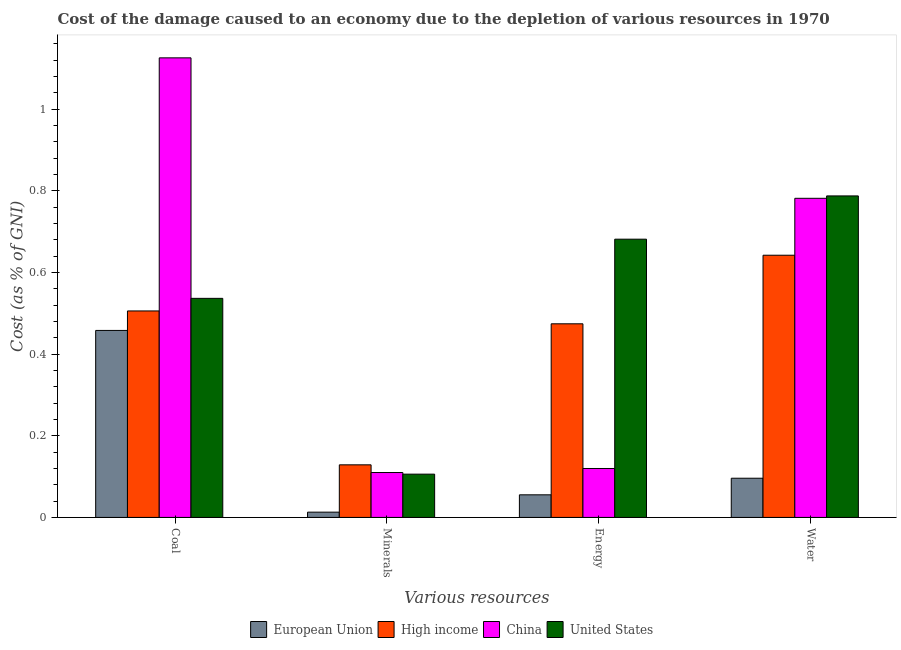How many groups of bars are there?
Give a very brief answer. 4. Are the number of bars per tick equal to the number of legend labels?
Make the answer very short. Yes. How many bars are there on the 3rd tick from the left?
Provide a short and direct response. 4. How many bars are there on the 3rd tick from the right?
Give a very brief answer. 4. What is the label of the 3rd group of bars from the left?
Your answer should be compact. Energy. What is the cost of damage due to depletion of coal in High income?
Provide a short and direct response. 0.51. Across all countries, what is the maximum cost of damage due to depletion of minerals?
Your answer should be compact. 0.13. Across all countries, what is the minimum cost of damage due to depletion of water?
Provide a succinct answer. 0.1. In which country was the cost of damage due to depletion of minerals minimum?
Your response must be concise. European Union. What is the total cost of damage due to depletion of coal in the graph?
Give a very brief answer. 2.63. What is the difference between the cost of damage due to depletion of energy in High income and that in United States?
Ensure brevity in your answer.  -0.21. What is the difference between the cost of damage due to depletion of minerals in United States and the cost of damage due to depletion of coal in European Union?
Provide a succinct answer. -0.35. What is the average cost of damage due to depletion of water per country?
Offer a terse response. 0.58. What is the difference between the cost of damage due to depletion of water and cost of damage due to depletion of minerals in European Union?
Offer a very short reply. 0.08. What is the ratio of the cost of damage due to depletion of water in United States to that in European Union?
Give a very brief answer. 8.2. Is the cost of damage due to depletion of coal in United States less than that in European Union?
Provide a succinct answer. No. What is the difference between the highest and the second highest cost of damage due to depletion of energy?
Ensure brevity in your answer.  0.21. What is the difference between the highest and the lowest cost of damage due to depletion of coal?
Ensure brevity in your answer.  0.67. In how many countries, is the cost of damage due to depletion of coal greater than the average cost of damage due to depletion of coal taken over all countries?
Offer a terse response. 1. Is the sum of the cost of damage due to depletion of coal in China and High income greater than the maximum cost of damage due to depletion of minerals across all countries?
Your answer should be compact. Yes. How many countries are there in the graph?
Your answer should be very brief. 4. Does the graph contain grids?
Give a very brief answer. No. Where does the legend appear in the graph?
Give a very brief answer. Bottom center. How are the legend labels stacked?
Provide a short and direct response. Horizontal. What is the title of the graph?
Give a very brief answer. Cost of the damage caused to an economy due to the depletion of various resources in 1970 . Does "Armenia" appear as one of the legend labels in the graph?
Your response must be concise. No. What is the label or title of the X-axis?
Your answer should be compact. Various resources. What is the label or title of the Y-axis?
Your response must be concise. Cost (as % of GNI). What is the Cost (as % of GNI) of European Union in Coal?
Your response must be concise. 0.46. What is the Cost (as % of GNI) of High income in Coal?
Offer a terse response. 0.51. What is the Cost (as % of GNI) in China in Coal?
Your response must be concise. 1.13. What is the Cost (as % of GNI) in United States in Coal?
Your answer should be very brief. 0.54. What is the Cost (as % of GNI) in European Union in Minerals?
Provide a succinct answer. 0.01. What is the Cost (as % of GNI) of High income in Minerals?
Your answer should be compact. 0.13. What is the Cost (as % of GNI) in China in Minerals?
Offer a terse response. 0.11. What is the Cost (as % of GNI) of United States in Minerals?
Provide a succinct answer. 0.11. What is the Cost (as % of GNI) of European Union in Energy?
Make the answer very short. 0.06. What is the Cost (as % of GNI) of High income in Energy?
Keep it short and to the point. 0.47. What is the Cost (as % of GNI) of China in Energy?
Your answer should be very brief. 0.12. What is the Cost (as % of GNI) in United States in Energy?
Make the answer very short. 0.68. What is the Cost (as % of GNI) in European Union in Water?
Your answer should be compact. 0.1. What is the Cost (as % of GNI) of High income in Water?
Make the answer very short. 0.64. What is the Cost (as % of GNI) of China in Water?
Provide a short and direct response. 0.78. What is the Cost (as % of GNI) of United States in Water?
Offer a terse response. 0.79. Across all Various resources, what is the maximum Cost (as % of GNI) of European Union?
Give a very brief answer. 0.46. Across all Various resources, what is the maximum Cost (as % of GNI) of High income?
Provide a short and direct response. 0.64. Across all Various resources, what is the maximum Cost (as % of GNI) of China?
Your answer should be very brief. 1.13. Across all Various resources, what is the maximum Cost (as % of GNI) of United States?
Make the answer very short. 0.79. Across all Various resources, what is the minimum Cost (as % of GNI) of European Union?
Make the answer very short. 0.01. Across all Various resources, what is the minimum Cost (as % of GNI) of High income?
Provide a short and direct response. 0.13. Across all Various resources, what is the minimum Cost (as % of GNI) of China?
Provide a short and direct response. 0.11. Across all Various resources, what is the minimum Cost (as % of GNI) of United States?
Your answer should be very brief. 0.11. What is the total Cost (as % of GNI) of European Union in the graph?
Your answer should be compact. 0.62. What is the total Cost (as % of GNI) of High income in the graph?
Your answer should be very brief. 1.75. What is the total Cost (as % of GNI) in China in the graph?
Provide a short and direct response. 2.14. What is the total Cost (as % of GNI) of United States in the graph?
Your answer should be very brief. 2.11. What is the difference between the Cost (as % of GNI) of European Union in Coal and that in Minerals?
Make the answer very short. 0.45. What is the difference between the Cost (as % of GNI) of High income in Coal and that in Minerals?
Make the answer very short. 0.38. What is the difference between the Cost (as % of GNI) in China in Coal and that in Minerals?
Your answer should be very brief. 1.02. What is the difference between the Cost (as % of GNI) of United States in Coal and that in Minerals?
Ensure brevity in your answer.  0.43. What is the difference between the Cost (as % of GNI) in European Union in Coal and that in Energy?
Your answer should be compact. 0.4. What is the difference between the Cost (as % of GNI) in High income in Coal and that in Energy?
Your answer should be compact. 0.03. What is the difference between the Cost (as % of GNI) of China in Coal and that in Energy?
Your answer should be very brief. 1.01. What is the difference between the Cost (as % of GNI) of United States in Coal and that in Energy?
Ensure brevity in your answer.  -0.14. What is the difference between the Cost (as % of GNI) in European Union in Coal and that in Water?
Your response must be concise. 0.36. What is the difference between the Cost (as % of GNI) of High income in Coal and that in Water?
Your answer should be very brief. -0.14. What is the difference between the Cost (as % of GNI) of China in Coal and that in Water?
Offer a very short reply. 0.34. What is the difference between the Cost (as % of GNI) in United States in Coal and that in Water?
Your answer should be very brief. -0.25. What is the difference between the Cost (as % of GNI) in European Union in Minerals and that in Energy?
Make the answer very short. -0.04. What is the difference between the Cost (as % of GNI) in High income in Minerals and that in Energy?
Ensure brevity in your answer.  -0.35. What is the difference between the Cost (as % of GNI) in China in Minerals and that in Energy?
Your answer should be very brief. -0.01. What is the difference between the Cost (as % of GNI) in United States in Minerals and that in Energy?
Offer a terse response. -0.58. What is the difference between the Cost (as % of GNI) in European Union in Minerals and that in Water?
Keep it short and to the point. -0.08. What is the difference between the Cost (as % of GNI) of High income in Minerals and that in Water?
Give a very brief answer. -0.51. What is the difference between the Cost (as % of GNI) in China in Minerals and that in Water?
Provide a short and direct response. -0.67. What is the difference between the Cost (as % of GNI) of United States in Minerals and that in Water?
Keep it short and to the point. -0.68. What is the difference between the Cost (as % of GNI) of European Union in Energy and that in Water?
Make the answer very short. -0.04. What is the difference between the Cost (as % of GNI) in High income in Energy and that in Water?
Give a very brief answer. -0.17. What is the difference between the Cost (as % of GNI) of China in Energy and that in Water?
Offer a terse response. -0.66. What is the difference between the Cost (as % of GNI) in United States in Energy and that in Water?
Offer a terse response. -0.11. What is the difference between the Cost (as % of GNI) of European Union in Coal and the Cost (as % of GNI) of High income in Minerals?
Give a very brief answer. 0.33. What is the difference between the Cost (as % of GNI) of European Union in Coal and the Cost (as % of GNI) of China in Minerals?
Provide a succinct answer. 0.35. What is the difference between the Cost (as % of GNI) of European Union in Coal and the Cost (as % of GNI) of United States in Minerals?
Offer a very short reply. 0.35. What is the difference between the Cost (as % of GNI) in High income in Coal and the Cost (as % of GNI) in China in Minerals?
Offer a terse response. 0.4. What is the difference between the Cost (as % of GNI) in High income in Coal and the Cost (as % of GNI) in United States in Minerals?
Provide a succinct answer. 0.4. What is the difference between the Cost (as % of GNI) of China in Coal and the Cost (as % of GNI) of United States in Minerals?
Make the answer very short. 1.02. What is the difference between the Cost (as % of GNI) of European Union in Coal and the Cost (as % of GNI) of High income in Energy?
Offer a very short reply. -0.02. What is the difference between the Cost (as % of GNI) of European Union in Coal and the Cost (as % of GNI) of China in Energy?
Offer a very short reply. 0.34. What is the difference between the Cost (as % of GNI) of European Union in Coal and the Cost (as % of GNI) of United States in Energy?
Make the answer very short. -0.22. What is the difference between the Cost (as % of GNI) in High income in Coal and the Cost (as % of GNI) in China in Energy?
Your answer should be compact. 0.39. What is the difference between the Cost (as % of GNI) of High income in Coal and the Cost (as % of GNI) of United States in Energy?
Your response must be concise. -0.18. What is the difference between the Cost (as % of GNI) in China in Coal and the Cost (as % of GNI) in United States in Energy?
Your answer should be very brief. 0.44. What is the difference between the Cost (as % of GNI) of European Union in Coal and the Cost (as % of GNI) of High income in Water?
Give a very brief answer. -0.18. What is the difference between the Cost (as % of GNI) of European Union in Coal and the Cost (as % of GNI) of China in Water?
Your response must be concise. -0.32. What is the difference between the Cost (as % of GNI) of European Union in Coal and the Cost (as % of GNI) of United States in Water?
Offer a terse response. -0.33. What is the difference between the Cost (as % of GNI) in High income in Coal and the Cost (as % of GNI) in China in Water?
Provide a succinct answer. -0.28. What is the difference between the Cost (as % of GNI) of High income in Coal and the Cost (as % of GNI) of United States in Water?
Offer a very short reply. -0.28. What is the difference between the Cost (as % of GNI) in China in Coal and the Cost (as % of GNI) in United States in Water?
Your response must be concise. 0.34. What is the difference between the Cost (as % of GNI) of European Union in Minerals and the Cost (as % of GNI) of High income in Energy?
Make the answer very short. -0.46. What is the difference between the Cost (as % of GNI) of European Union in Minerals and the Cost (as % of GNI) of China in Energy?
Make the answer very short. -0.11. What is the difference between the Cost (as % of GNI) in European Union in Minerals and the Cost (as % of GNI) in United States in Energy?
Your answer should be very brief. -0.67. What is the difference between the Cost (as % of GNI) of High income in Minerals and the Cost (as % of GNI) of China in Energy?
Offer a very short reply. 0.01. What is the difference between the Cost (as % of GNI) of High income in Minerals and the Cost (as % of GNI) of United States in Energy?
Offer a terse response. -0.55. What is the difference between the Cost (as % of GNI) in China in Minerals and the Cost (as % of GNI) in United States in Energy?
Your answer should be very brief. -0.57. What is the difference between the Cost (as % of GNI) of European Union in Minerals and the Cost (as % of GNI) of High income in Water?
Give a very brief answer. -0.63. What is the difference between the Cost (as % of GNI) of European Union in Minerals and the Cost (as % of GNI) of China in Water?
Keep it short and to the point. -0.77. What is the difference between the Cost (as % of GNI) of European Union in Minerals and the Cost (as % of GNI) of United States in Water?
Give a very brief answer. -0.77. What is the difference between the Cost (as % of GNI) of High income in Minerals and the Cost (as % of GNI) of China in Water?
Give a very brief answer. -0.65. What is the difference between the Cost (as % of GNI) of High income in Minerals and the Cost (as % of GNI) of United States in Water?
Provide a short and direct response. -0.66. What is the difference between the Cost (as % of GNI) of China in Minerals and the Cost (as % of GNI) of United States in Water?
Offer a terse response. -0.68. What is the difference between the Cost (as % of GNI) of European Union in Energy and the Cost (as % of GNI) of High income in Water?
Your answer should be compact. -0.59. What is the difference between the Cost (as % of GNI) in European Union in Energy and the Cost (as % of GNI) in China in Water?
Offer a terse response. -0.73. What is the difference between the Cost (as % of GNI) of European Union in Energy and the Cost (as % of GNI) of United States in Water?
Ensure brevity in your answer.  -0.73. What is the difference between the Cost (as % of GNI) of High income in Energy and the Cost (as % of GNI) of China in Water?
Provide a succinct answer. -0.31. What is the difference between the Cost (as % of GNI) of High income in Energy and the Cost (as % of GNI) of United States in Water?
Your response must be concise. -0.31. What is the difference between the Cost (as % of GNI) of China in Energy and the Cost (as % of GNI) of United States in Water?
Keep it short and to the point. -0.67. What is the average Cost (as % of GNI) in European Union per Various resources?
Provide a succinct answer. 0.16. What is the average Cost (as % of GNI) of High income per Various resources?
Your answer should be very brief. 0.44. What is the average Cost (as % of GNI) in China per Various resources?
Your response must be concise. 0.53. What is the average Cost (as % of GNI) of United States per Various resources?
Give a very brief answer. 0.53. What is the difference between the Cost (as % of GNI) in European Union and Cost (as % of GNI) in High income in Coal?
Your response must be concise. -0.05. What is the difference between the Cost (as % of GNI) of European Union and Cost (as % of GNI) of China in Coal?
Provide a short and direct response. -0.67. What is the difference between the Cost (as % of GNI) in European Union and Cost (as % of GNI) in United States in Coal?
Keep it short and to the point. -0.08. What is the difference between the Cost (as % of GNI) in High income and Cost (as % of GNI) in China in Coal?
Offer a terse response. -0.62. What is the difference between the Cost (as % of GNI) in High income and Cost (as % of GNI) in United States in Coal?
Give a very brief answer. -0.03. What is the difference between the Cost (as % of GNI) of China and Cost (as % of GNI) of United States in Coal?
Offer a terse response. 0.59. What is the difference between the Cost (as % of GNI) of European Union and Cost (as % of GNI) of High income in Minerals?
Ensure brevity in your answer.  -0.12. What is the difference between the Cost (as % of GNI) of European Union and Cost (as % of GNI) of China in Minerals?
Provide a short and direct response. -0.1. What is the difference between the Cost (as % of GNI) in European Union and Cost (as % of GNI) in United States in Minerals?
Keep it short and to the point. -0.09. What is the difference between the Cost (as % of GNI) of High income and Cost (as % of GNI) of China in Minerals?
Provide a succinct answer. 0.02. What is the difference between the Cost (as % of GNI) of High income and Cost (as % of GNI) of United States in Minerals?
Provide a short and direct response. 0.02. What is the difference between the Cost (as % of GNI) of China and Cost (as % of GNI) of United States in Minerals?
Your answer should be compact. 0. What is the difference between the Cost (as % of GNI) of European Union and Cost (as % of GNI) of High income in Energy?
Offer a terse response. -0.42. What is the difference between the Cost (as % of GNI) in European Union and Cost (as % of GNI) in China in Energy?
Offer a very short reply. -0.06. What is the difference between the Cost (as % of GNI) of European Union and Cost (as % of GNI) of United States in Energy?
Your response must be concise. -0.63. What is the difference between the Cost (as % of GNI) of High income and Cost (as % of GNI) of China in Energy?
Ensure brevity in your answer.  0.35. What is the difference between the Cost (as % of GNI) of High income and Cost (as % of GNI) of United States in Energy?
Your response must be concise. -0.21. What is the difference between the Cost (as % of GNI) in China and Cost (as % of GNI) in United States in Energy?
Make the answer very short. -0.56. What is the difference between the Cost (as % of GNI) of European Union and Cost (as % of GNI) of High income in Water?
Ensure brevity in your answer.  -0.55. What is the difference between the Cost (as % of GNI) of European Union and Cost (as % of GNI) of China in Water?
Give a very brief answer. -0.69. What is the difference between the Cost (as % of GNI) in European Union and Cost (as % of GNI) in United States in Water?
Give a very brief answer. -0.69. What is the difference between the Cost (as % of GNI) of High income and Cost (as % of GNI) of China in Water?
Provide a short and direct response. -0.14. What is the difference between the Cost (as % of GNI) of High income and Cost (as % of GNI) of United States in Water?
Provide a succinct answer. -0.15. What is the difference between the Cost (as % of GNI) in China and Cost (as % of GNI) in United States in Water?
Your answer should be very brief. -0.01. What is the ratio of the Cost (as % of GNI) of European Union in Coal to that in Minerals?
Your answer should be compact. 35.45. What is the ratio of the Cost (as % of GNI) of High income in Coal to that in Minerals?
Provide a short and direct response. 3.93. What is the ratio of the Cost (as % of GNI) of China in Coal to that in Minerals?
Your answer should be very brief. 10.23. What is the ratio of the Cost (as % of GNI) in United States in Coal to that in Minerals?
Your response must be concise. 5.06. What is the ratio of the Cost (as % of GNI) of European Union in Coal to that in Energy?
Make the answer very short. 8.27. What is the ratio of the Cost (as % of GNI) of High income in Coal to that in Energy?
Offer a terse response. 1.07. What is the ratio of the Cost (as % of GNI) in China in Coal to that in Energy?
Your answer should be very brief. 9.39. What is the ratio of the Cost (as % of GNI) of United States in Coal to that in Energy?
Offer a terse response. 0.79. What is the ratio of the Cost (as % of GNI) in European Union in Coal to that in Water?
Provide a short and direct response. 4.77. What is the ratio of the Cost (as % of GNI) of High income in Coal to that in Water?
Keep it short and to the point. 0.79. What is the ratio of the Cost (as % of GNI) in China in Coal to that in Water?
Your response must be concise. 1.44. What is the ratio of the Cost (as % of GNI) in United States in Coal to that in Water?
Offer a very short reply. 0.68. What is the ratio of the Cost (as % of GNI) of European Union in Minerals to that in Energy?
Give a very brief answer. 0.23. What is the ratio of the Cost (as % of GNI) of High income in Minerals to that in Energy?
Provide a succinct answer. 0.27. What is the ratio of the Cost (as % of GNI) in China in Minerals to that in Energy?
Provide a succinct answer. 0.92. What is the ratio of the Cost (as % of GNI) of United States in Minerals to that in Energy?
Ensure brevity in your answer.  0.16. What is the ratio of the Cost (as % of GNI) of European Union in Minerals to that in Water?
Keep it short and to the point. 0.13. What is the ratio of the Cost (as % of GNI) of High income in Minerals to that in Water?
Provide a short and direct response. 0.2. What is the ratio of the Cost (as % of GNI) of China in Minerals to that in Water?
Offer a terse response. 0.14. What is the ratio of the Cost (as % of GNI) of United States in Minerals to that in Water?
Make the answer very short. 0.13. What is the ratio of the Cost (as % of GNI) of European Union in Energy to that in Water?
Offer a terse response. 0.58. What is the ratio of the Cost (as % of GNI) in High income in Energy to that in Water?
Provide a short and direct response. 0.74. What is the ratio of the Cost (as % of GNI) of China in Energy to that in Water?
Offer a terse response. 0.15. What is the ratio of the Cost (as % of GNI) of United States in Energy to that in Water?
Offer a terse response. 0.87. What is the difference between the highest and the second highest Cost (as % of GNI) in European Union?
Provide a short and direct response. 0.36. What is the difference between the highest and the second highest Cost (as % of GNI) of High income?
Give a very brief answer. 0.14. What is the difference between the highest and the second highest Cost (as % of GNI) in China?
Make the answer very short. 0.34. What is the difference between the highest and the second highest Cost (as % of GNI) in United States?
Offer a very short reply. 0.11. What is the difference between the highest and the lowest Cost (as % of GNI) in European Union?
Make the answer very short. 0.45. What is the difference between the highest and the lowest Cost (as % of GNI) of High income?
Keep it short and to the point. 0.51. What is the difference between the highest and the lowest Cost (as % of GNI) in China?
Your answer should be compact. 1.02. What is the difference between the highest and the lowest Cost (as % of GNI) of United States?
Offer a terse response. 0.68. 